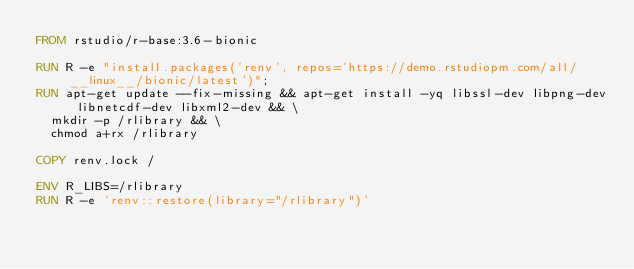Convert code to text. <code><loc_0><loc_0><loc_500><loc_500><_Dockerfile_>FROM rstudio/r-base:3.6-bionic

RUN R -e "install.packages('renv', repos='https://demo.rstudiopm.com/all/__linux__/bionic/latest')";
RUN apt-get update --fix-missing && apt-get install -yq libssl-dev libpng-dev libnetcdf-dev libxml2-dev && \
  mkdir -p /rlibrary && \
  chmod a+rx /rlibrary

COPY renv.lock /

ENV R_LIBS=/rlibrary
RUN R -e 'renv::restore(library="/rlibrary")'
</code> 